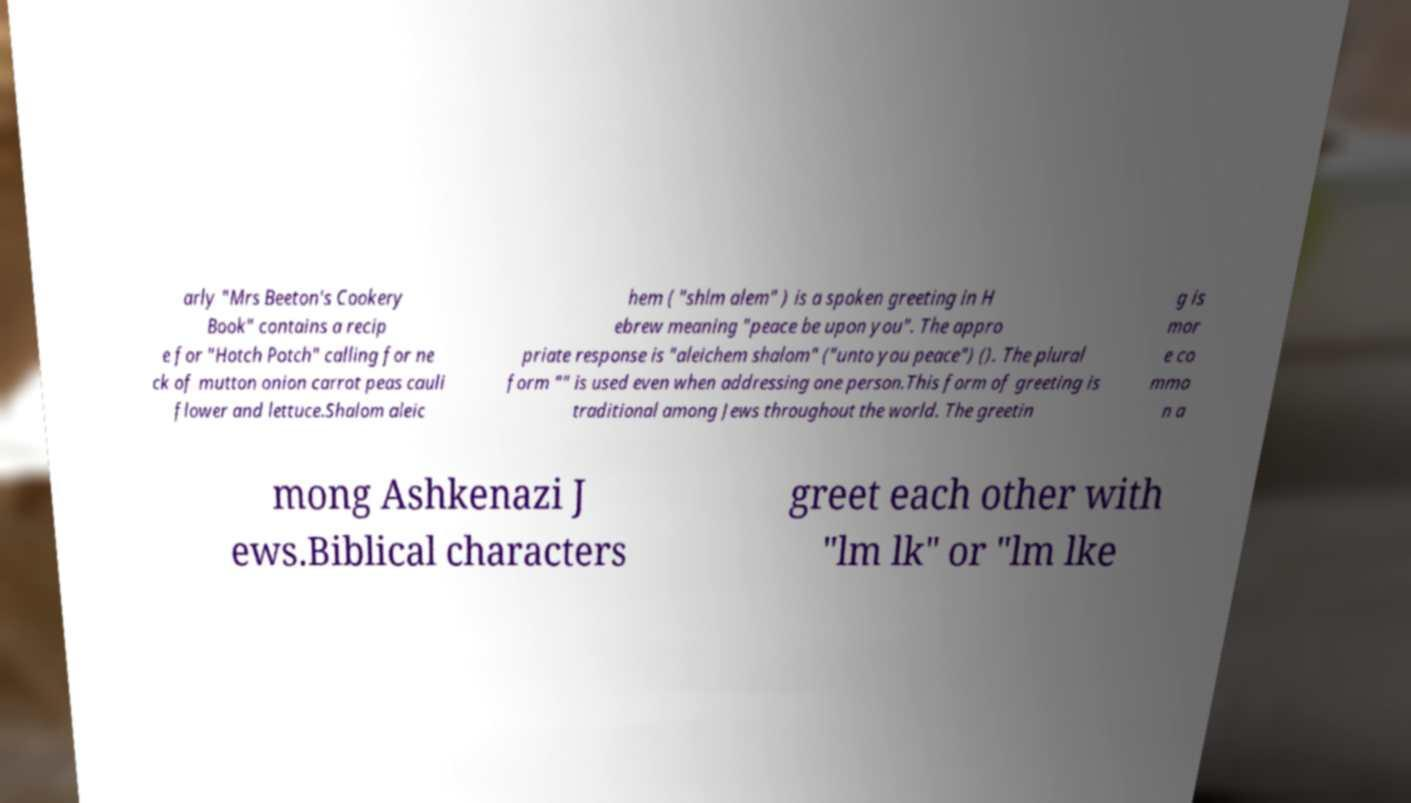Can you read and provide the text displayed in the image?This photo seems to have some interesting text. Can you extract and type it out for me? arly "Mrs Beeton's Cookery Book" contains a recip e for "Hotch Potch" calling for ne ck of mutton onion carrot peas cauli flower and lettuce.Shalom aleic hem ( "shlm alem" ) is a spoken greeting in H ebrew meaning "peace be upon you". The appro priate response is "aleichem shalom" ("unto you peace") (). The plural form "" is used even when addressing one person.This form of greeting is traditional among Jews throughout the world. The greetin g is mor e co mmo n a mong Ashkenazi J ews.Biblical characters greet each other with "lm lk" or "lm lke 